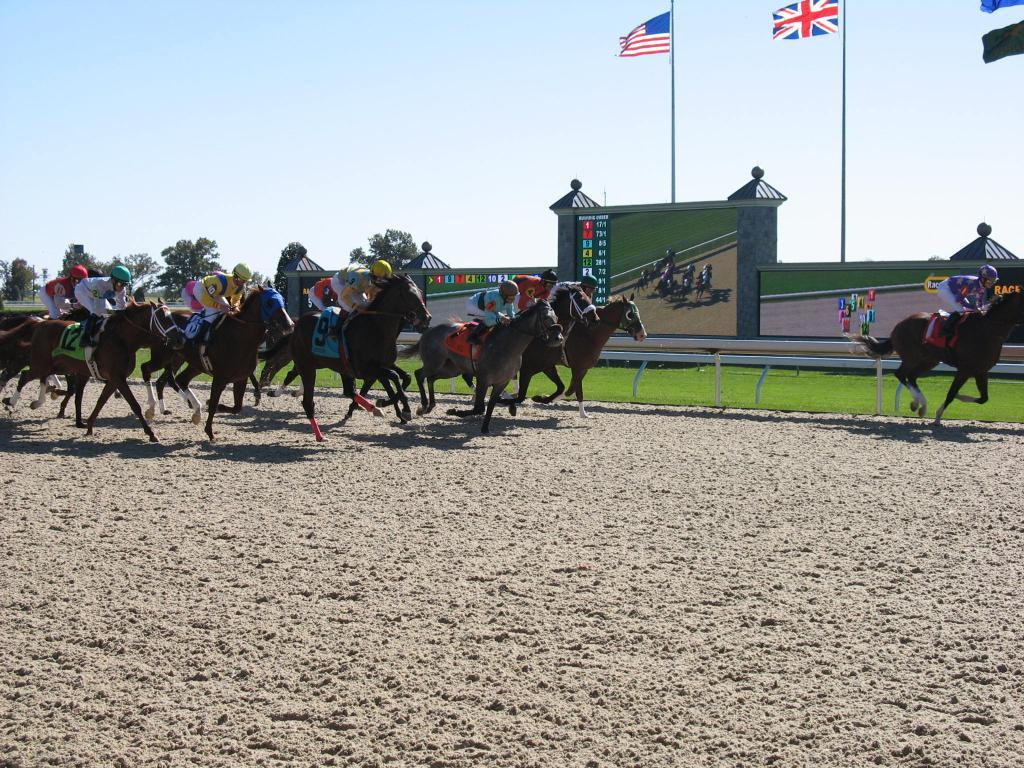What is happening in the image? A race is taking place in the image. What type of race is it? It is a horse race, as people are riding horses in the race. What can be seen in the background of the image? There are trees, a wall, a screen, and flags in the background of the image. What is the ground made of in the image? The ground is covered with grass in the image. What is the weather like in the image? The sky is clear in the image, suggesting good weather. What type of dress is the country wearing in the image? There is no country or dress present in the image; it features a horse race with people riding horses. What yard is visible in the image? There is no yard visible in the image; it features a race with people riding horses on grass. 